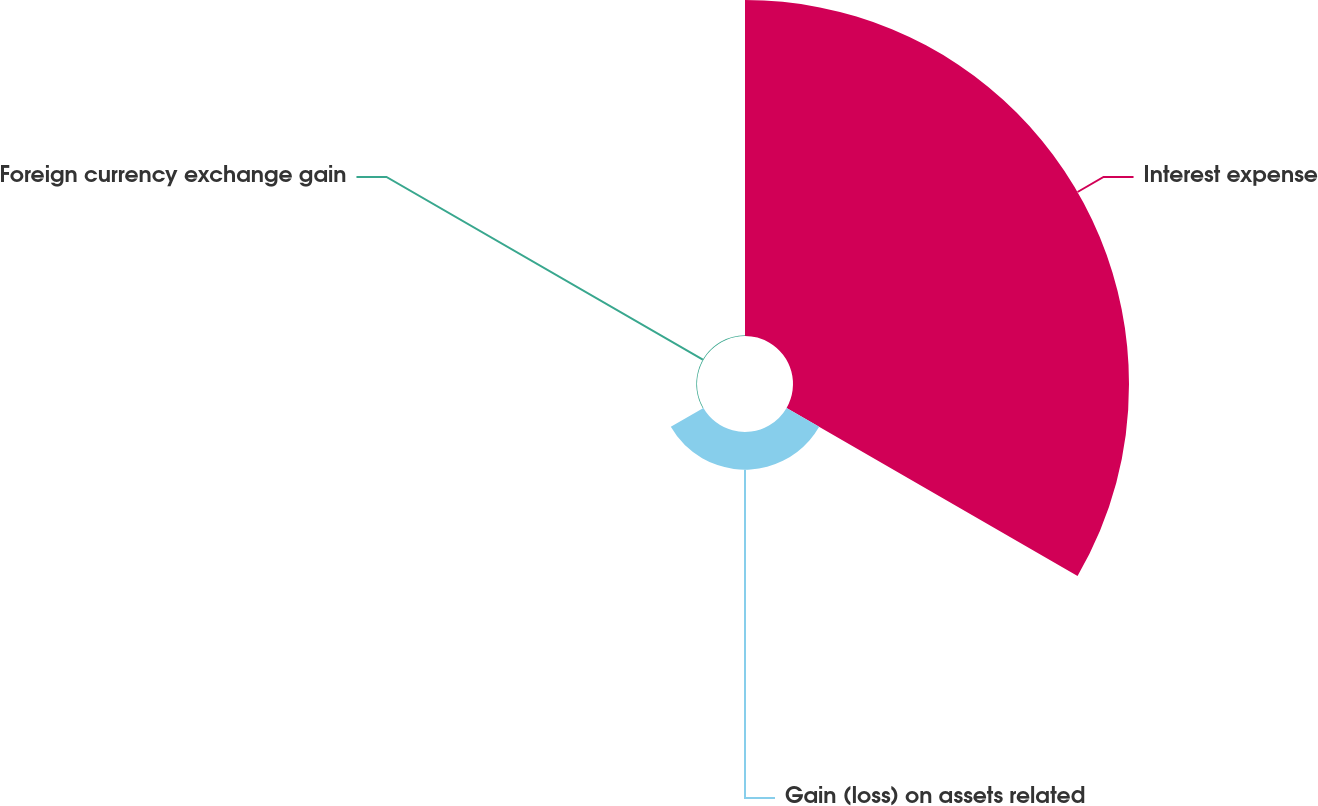Convert chart to OTSL. <chart><loc_0><loc_0><loc_500><loc_500><pie_chart><fcel>Interest expense<fcel>Gain (loss) on assets related<fcel>Foreign currency exchange gain<nl><fcel>89.75%<fcel>10.06%<fcel>0.19%<nl></chart> 